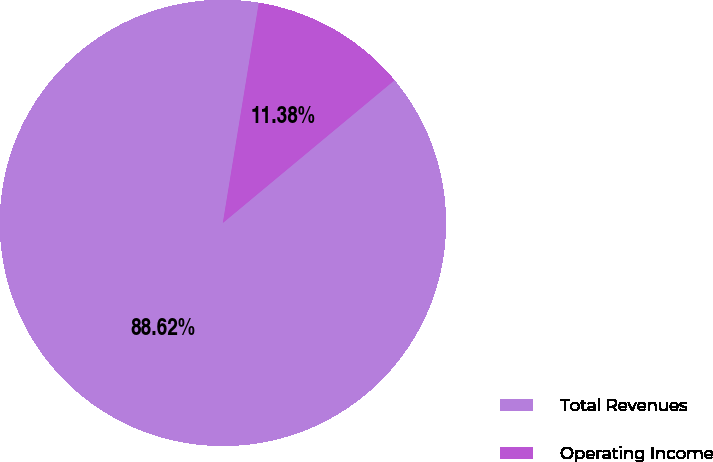Convert chart. <chart><loc_0><loc_0><loc_500><loc_500><pie_chart><fcel>Total Revenues<fcel>Operating Income<nl><fcel>88.62%<fcel>11.38%<nl></chart> 